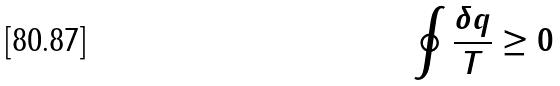Convert formula to latex. <formula><loc_0><loc_0><loc_500><loc_500>\oint \frac { \delta q } { T } \geq 0</formula> 